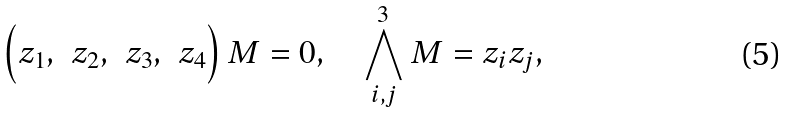Convert formula to latex. <formula><loc_0><loc_0><loc_500><loc_500>\left ( \begin{matrix} z _ { 1 } , & z _ { 2 } , & z _ { 3 } , & z _ { 4 } \end{matrix} \right ) M = 0 , \quad \bigwedge ^ { 3 } _ { i , j } M = z _ { i } z _ { j } ,</formula> 